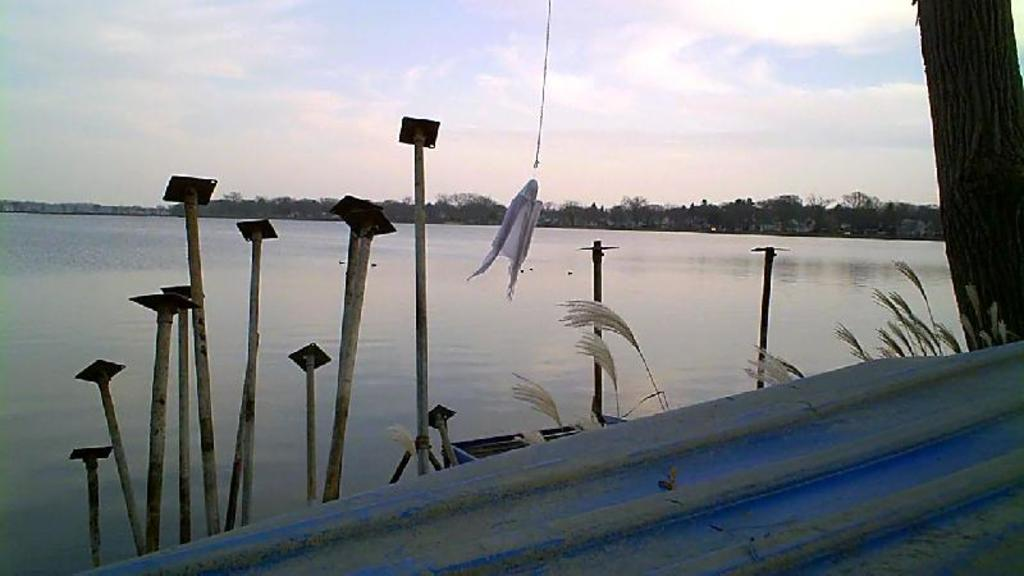What material is the sheet in the image made of? The sheet in the image is made of metal. What is the wooden pole used for in the image? The wooden pole's purpose is not explicitly stated in the image, but it could be used for support or as a marker. What type of vegetation is present in the image? There is grass and trees in the image. What body of water is visible in the image? There is a lake in the middle of the image. What structure is present near the lake? There is a dock in the image. What is the condition of the sky in the image? The sky is covered with clouds in the image. What type of kettle is being used to blow bubbles in the image? There is no kettle or bubbles in the image. 